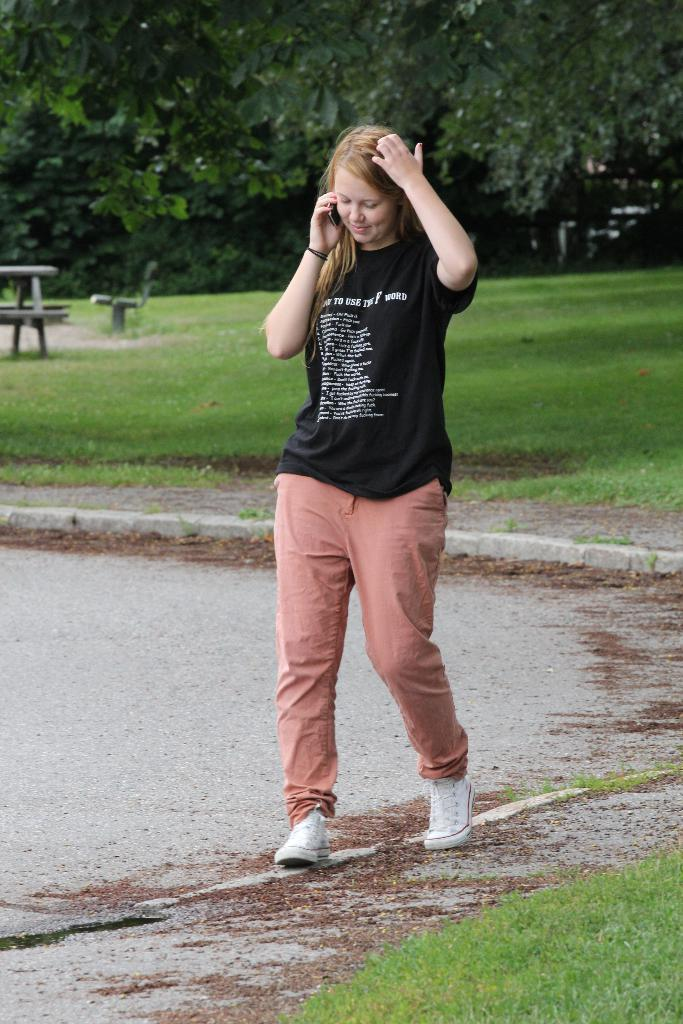Who is present in the image? There is a woman in the image. What is the woman doing in the image? The woman is standing on the ground. What object is the woman holding in her hand? The woman is holding a mobile in her hand. What can be seen in the background of the image? There is a group of trees in the background of the image. How many rats are visible in the image? There are no rats present in the image. Is there a boy in the image? The image only features a woman, so there is no boy present. 